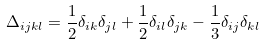Convert formula to latex. <formula><loc_0><loc_0><loc_500><loc_500>\Delta _ { i j k l } = \frac { 1 } { 2 } \delta _ { i k } \delta _ { j l } + \frac { 1 } { 2 } \delta _ { i l } \delta _ { j k } - \frac { 1 } { 3 } \delta _ { i j } \delta _ { k l }</formula> 